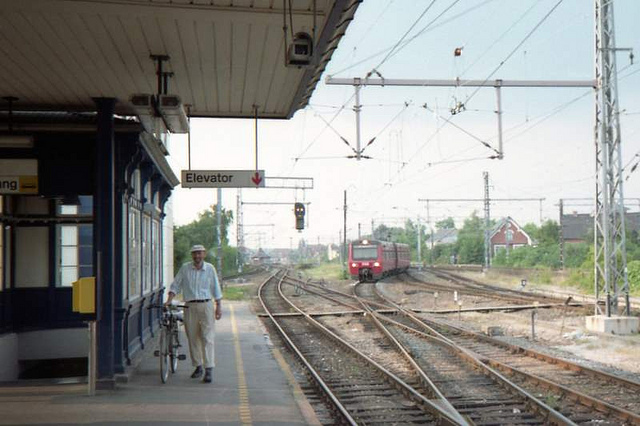Extract all visible text content from this image. Elevator ng 